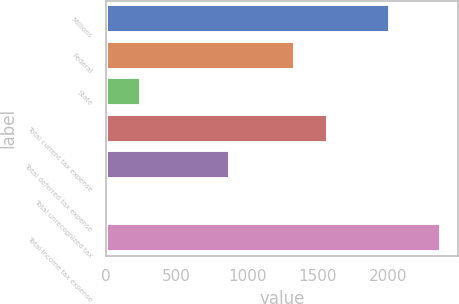Convert chart to OTSL. <chart><loc_0><loc_0><loc_500><loc_500><bar_chart><fcel>Millions<fcel>Federal<fcel>State<fcel>Total current tax expense<fcel>Total deferred tax expense<fcel>Total unrecognized tax<fcel>Total income tax expense<nl><fcel>2012<fcel>1335<fcel>243.8<fcel>1571.8<fcel>880<fcel>7<fcel>2375<nl></chart> 